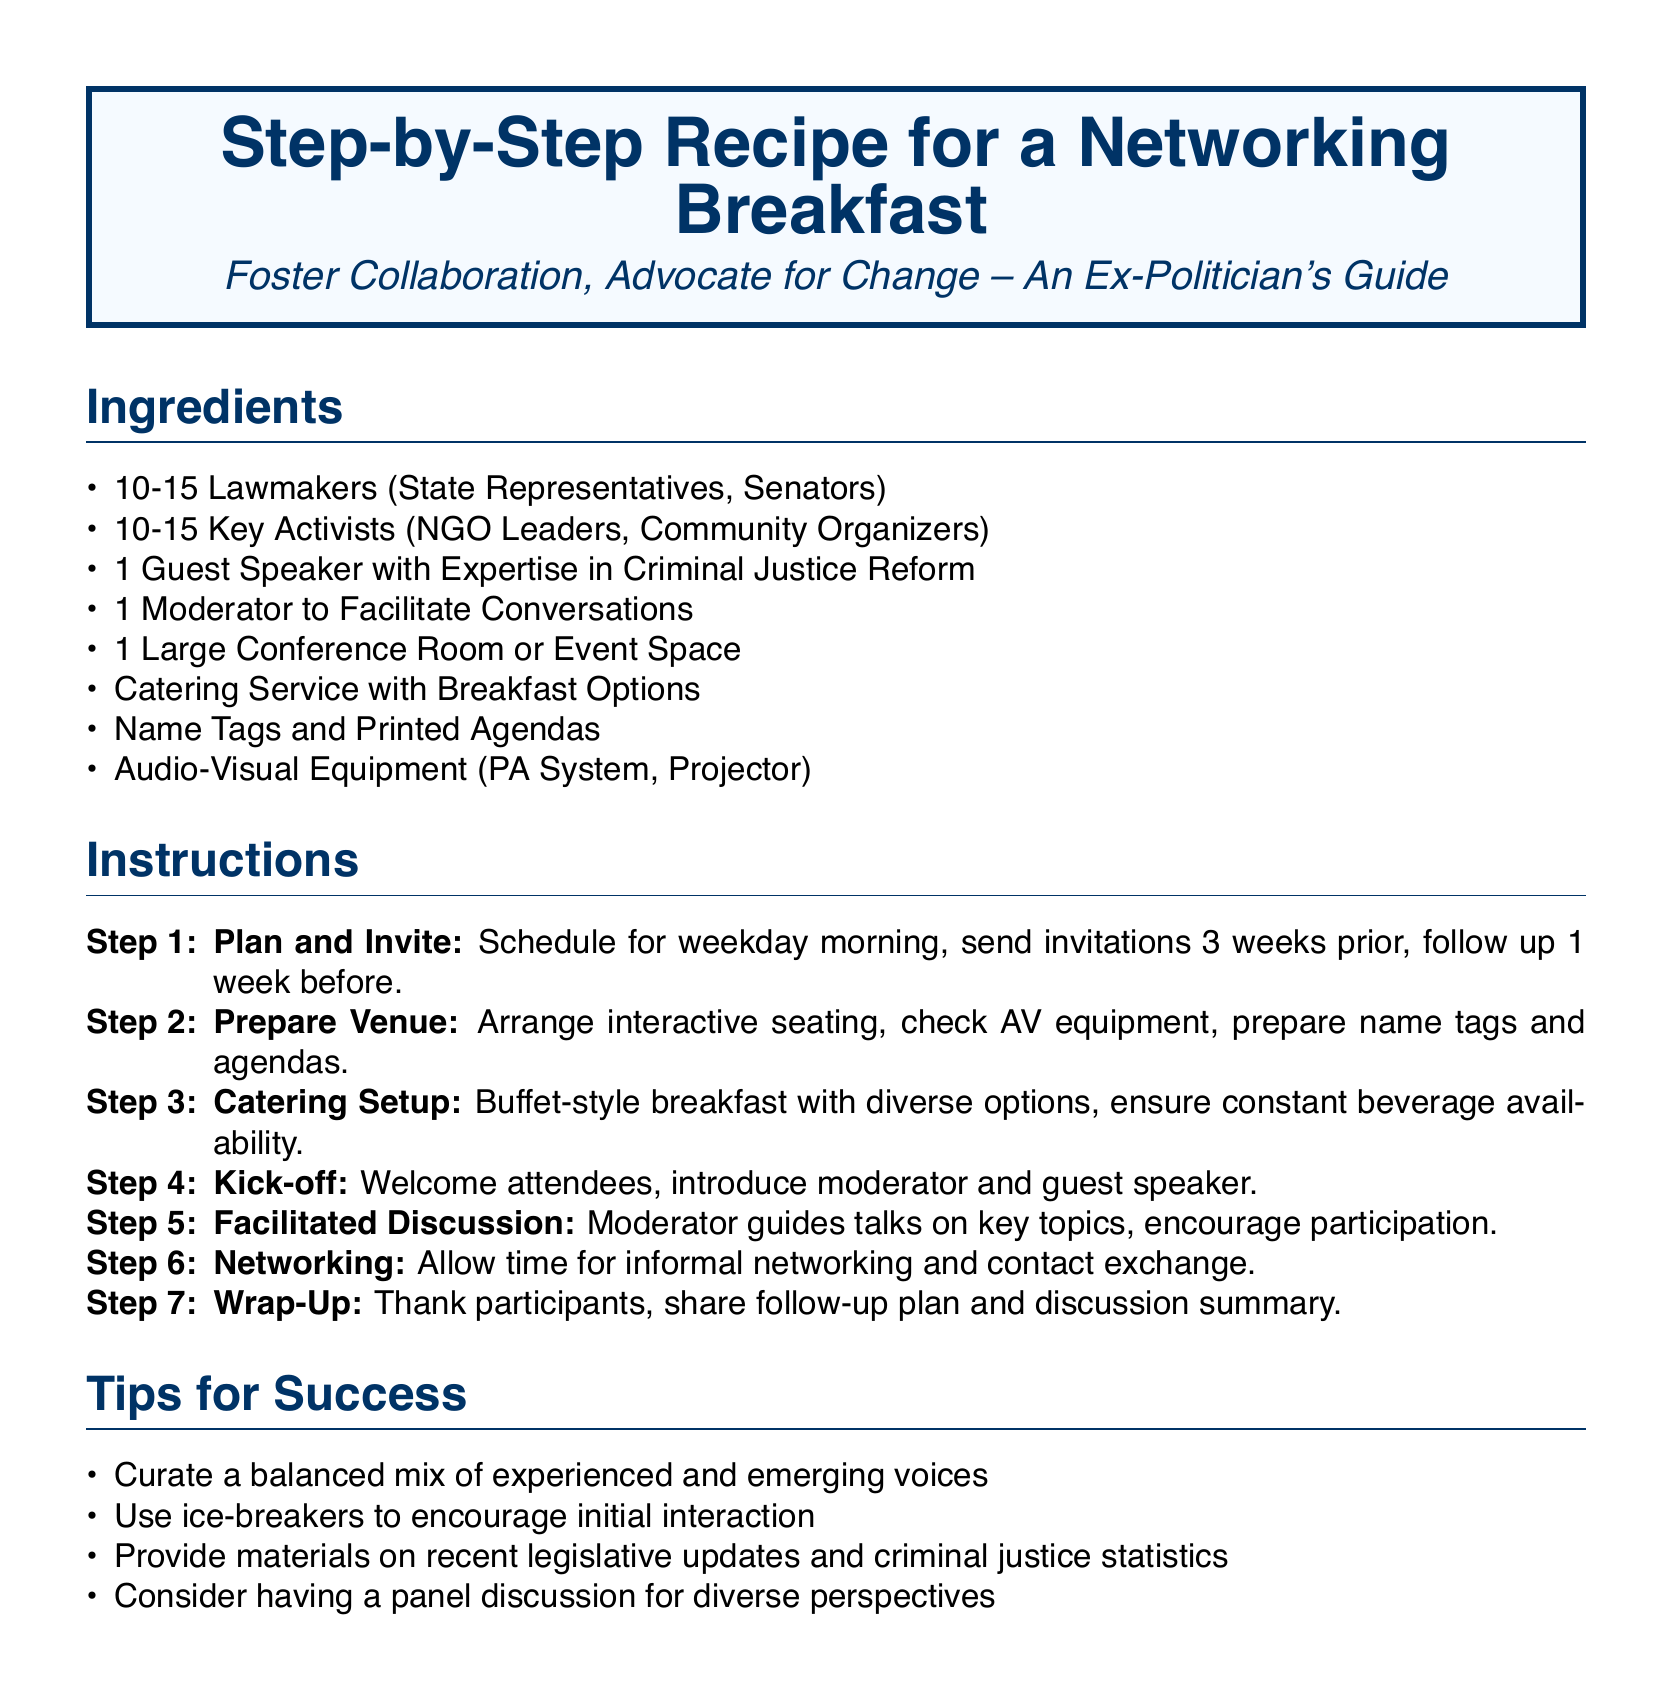what is the title of the document? The title of the document is prominently displayed at the top and reads "Step-by-Step Recipe for a Networking Breakfast".
Answer: Step-by-Step Recipe for a Networking Breakfast how many lawmakers are invited? The ingredients list specifies the number of lawmakers to invite, which is indicated as 10-15.
Answer: 10-15 what is required for the catering setup? The instructions list that the catering setup should include a buffet-style breakfast with diverse options and ensure constant beverage availability.
Answer: Buffet-style breakfast with diverse options who is responsible for facilitating conversations? The instructions specify that a moderator is needed to guide discussions during the networking breakfast.
Answer: Moderator what should be done three weeks prior to the event? The first instruction outlines that invitations should be sent three weeks before the event, making it a critical step in planning.
Answer: Send invitations what type of seating arrangement is suggested for the venue? The directions suggest arranging interactive seating for the attendees to foster communication and engagement during the breakfast.
Answer: Interactive seating why use ice-breakers during the event? The tips for success section mentions using ice-breakers to encourage initial interaction among participants, aiding in networking.
Answer: Encourage initial interaction how many steps are there in the instructions? The instructions for the networking breakfast are organized into a series of steps that total seven.
Answer: Seven what kind of speaker is recommended for the event? The ingredients list indicates that the event should include a guest speaker who has expertise in criminal justice reform.
Answer: Expertise in Criminal Justice Reform 